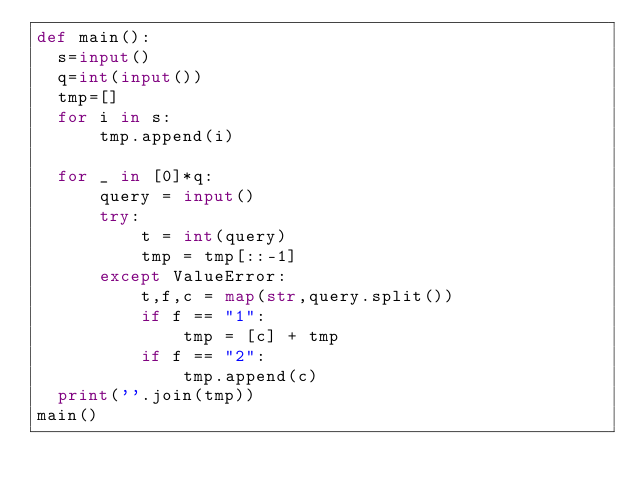<code> <loc_0><loc_0><loc_500><loc_500><_Python_>def main():
  s=input()
  q=int(input())
  tmp=[]
  for i in s:
      tmp.append(i)

  for _ in [0]*q:
      query = input()
      try:
          t = int(query)
          tmp = tmp[::-1]
      except ValueError:
          t,f,c = map(str,query.split())
          if f == "1":
              tmp = [c] + tmp
          if f == "2":
              tmp.append(c)
  print(''.join(tmp))
main()</code> 